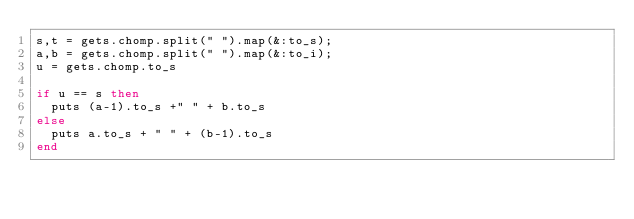Convert code to text. <code><loc_0><loc_0><loc_500><loc_500><_Ruby_>s,t = gets.chomp.split(" ").map(&:to_s);
a,b = gets.chomp.split(" ").map(&:to_i);
u = gets.chomp.to_s

if u == s then
	puts (a-1).to_s +" " + b.to_s
else
	puts a.to_s + " " + (b-1).to_s
end

</code> 